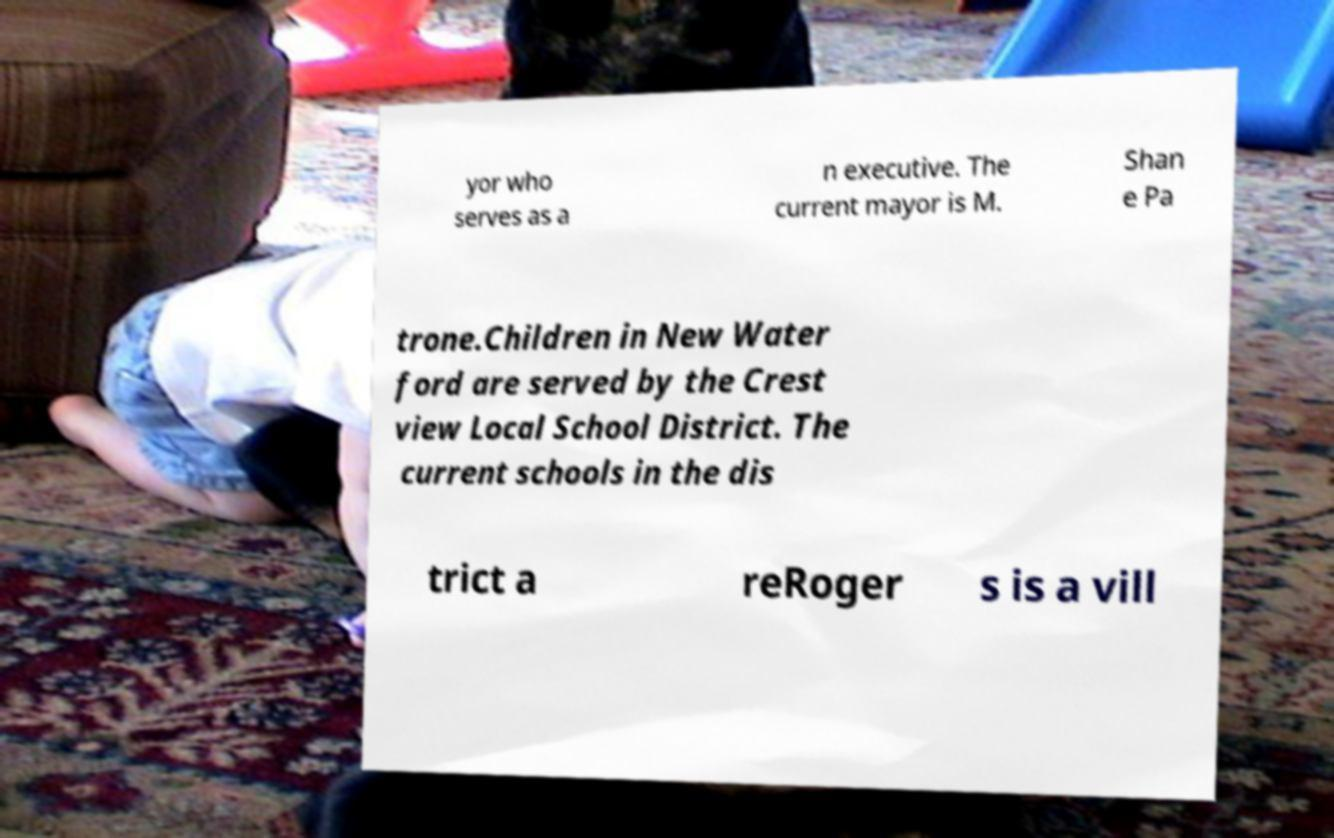What messages or text are displayed in this image? I need them in a readable, typed format. yor who serves as a n executive. The current mayor is M. Shan e Pa trone.Children in New Water ford are served by the Crest view Local School District. The current schools in the dis trict a reRoger s is a vill 